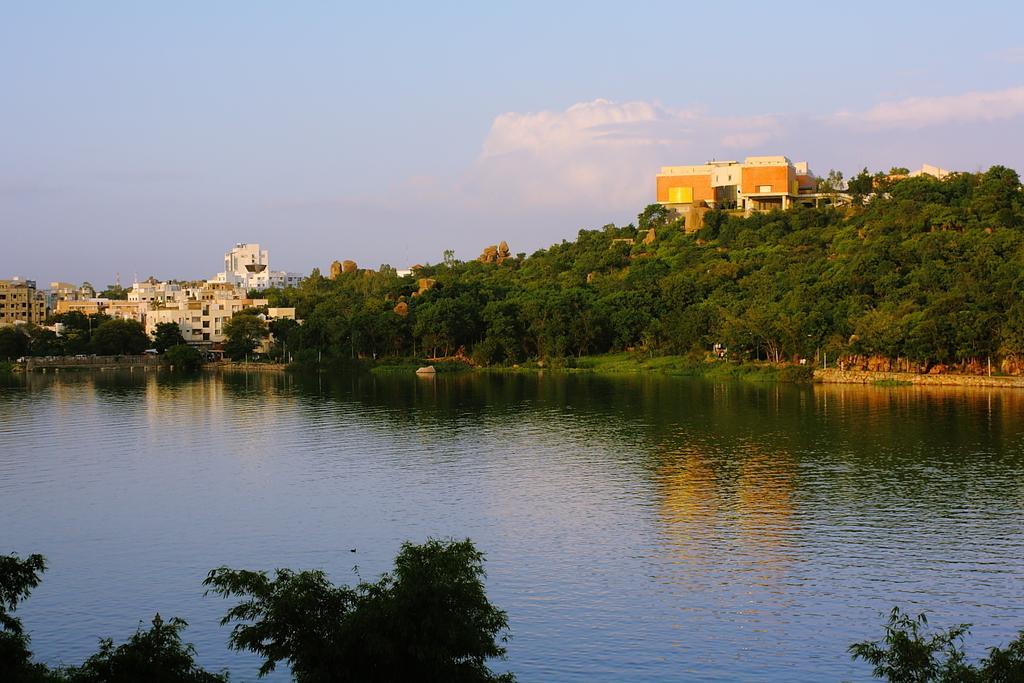Describe this image in one or two sentences. There is water. In the back there are trees, buildings and sky with clouds. 